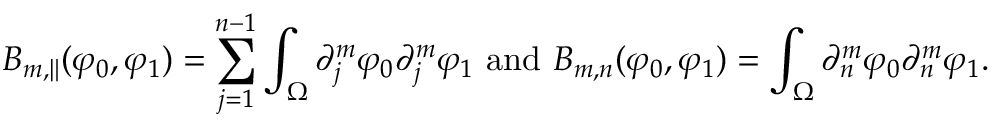Convert formula to latex. <formula><loc_0><loc_0><loc_500><loc_500>B _ { m , \| } ( \varphi _ { 0 } , \varphi _ { 1 } ) = \sum _ { j = 1 } ^ { n - 1 } \int _ { \Omega } \partial _ { j } ^ { m } \varphi _ { 0 } \partial _ { j } ^ { m } \varphi _ { 1 } a n d B _ { m , n } ( \varphi _ { 0 } , \varphi _ { 1 } ) = \int _ { \Omega } \partial _ { n } ^ { m } \varphi _ { 0 } \partial _ { n } ^ { m } \varphi _ { 1 } .</formula> 